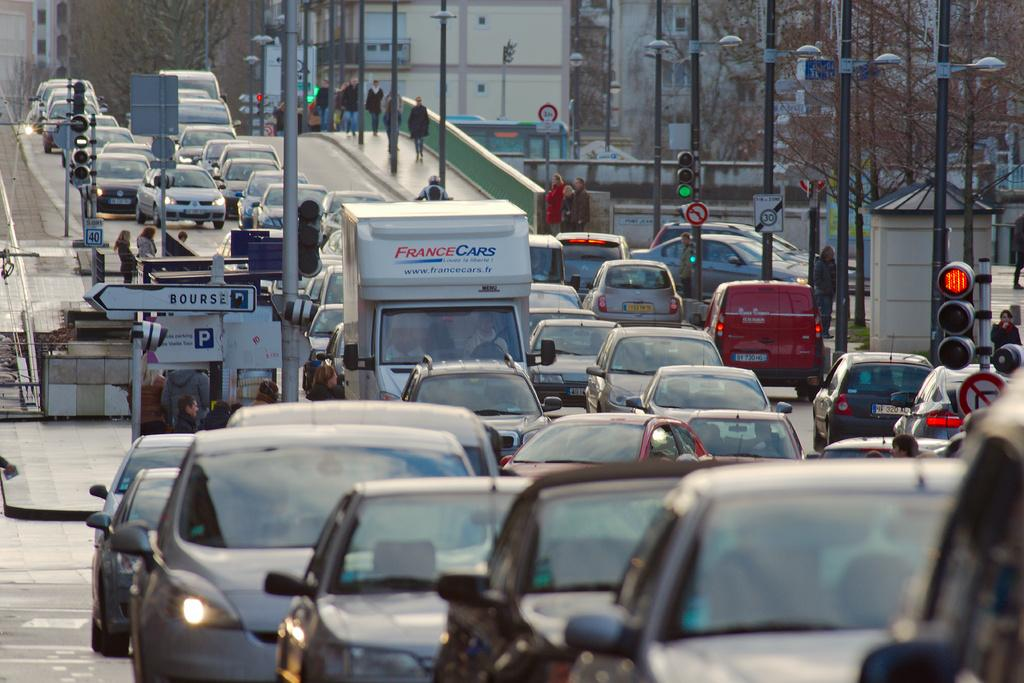What can be seen on the road in the image? There are vehicles on the road in the image. What objects are present in the image besides the vehicles? There are poles, boards, traffic signals, trees, buildings, and people in the image. What might be used to regulate traffic in the image? Traffic signals are present in the image to regulate traffic. What type of structures can be seen in the image? Buildings are present in the image. What type of cake is being served at the party in the image? There is no party or cake present in the image; it features vehicles on the road, poles, boards, traffic signals, trees, buildings, and people. What is the weight of the vase on the table in the image? There is no vase present in the image. 